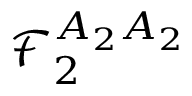Convert formula to latex. <formula><loc_0><loc_0><loc_500><loc_500>\mathcal { F } _ { 2 } ^ { A _ { 2 } A _ { 2 } }</formula> 